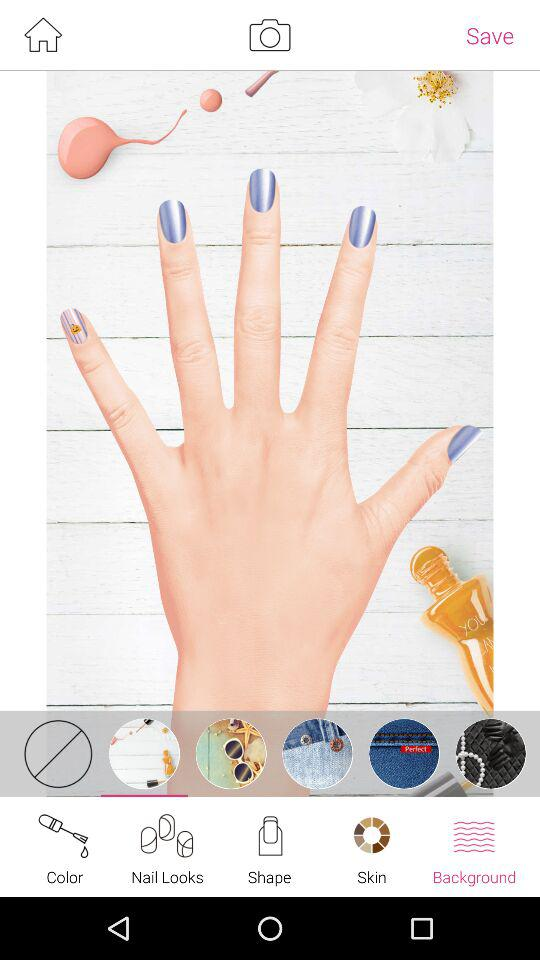Which tab am I on? The tab is "Background". 